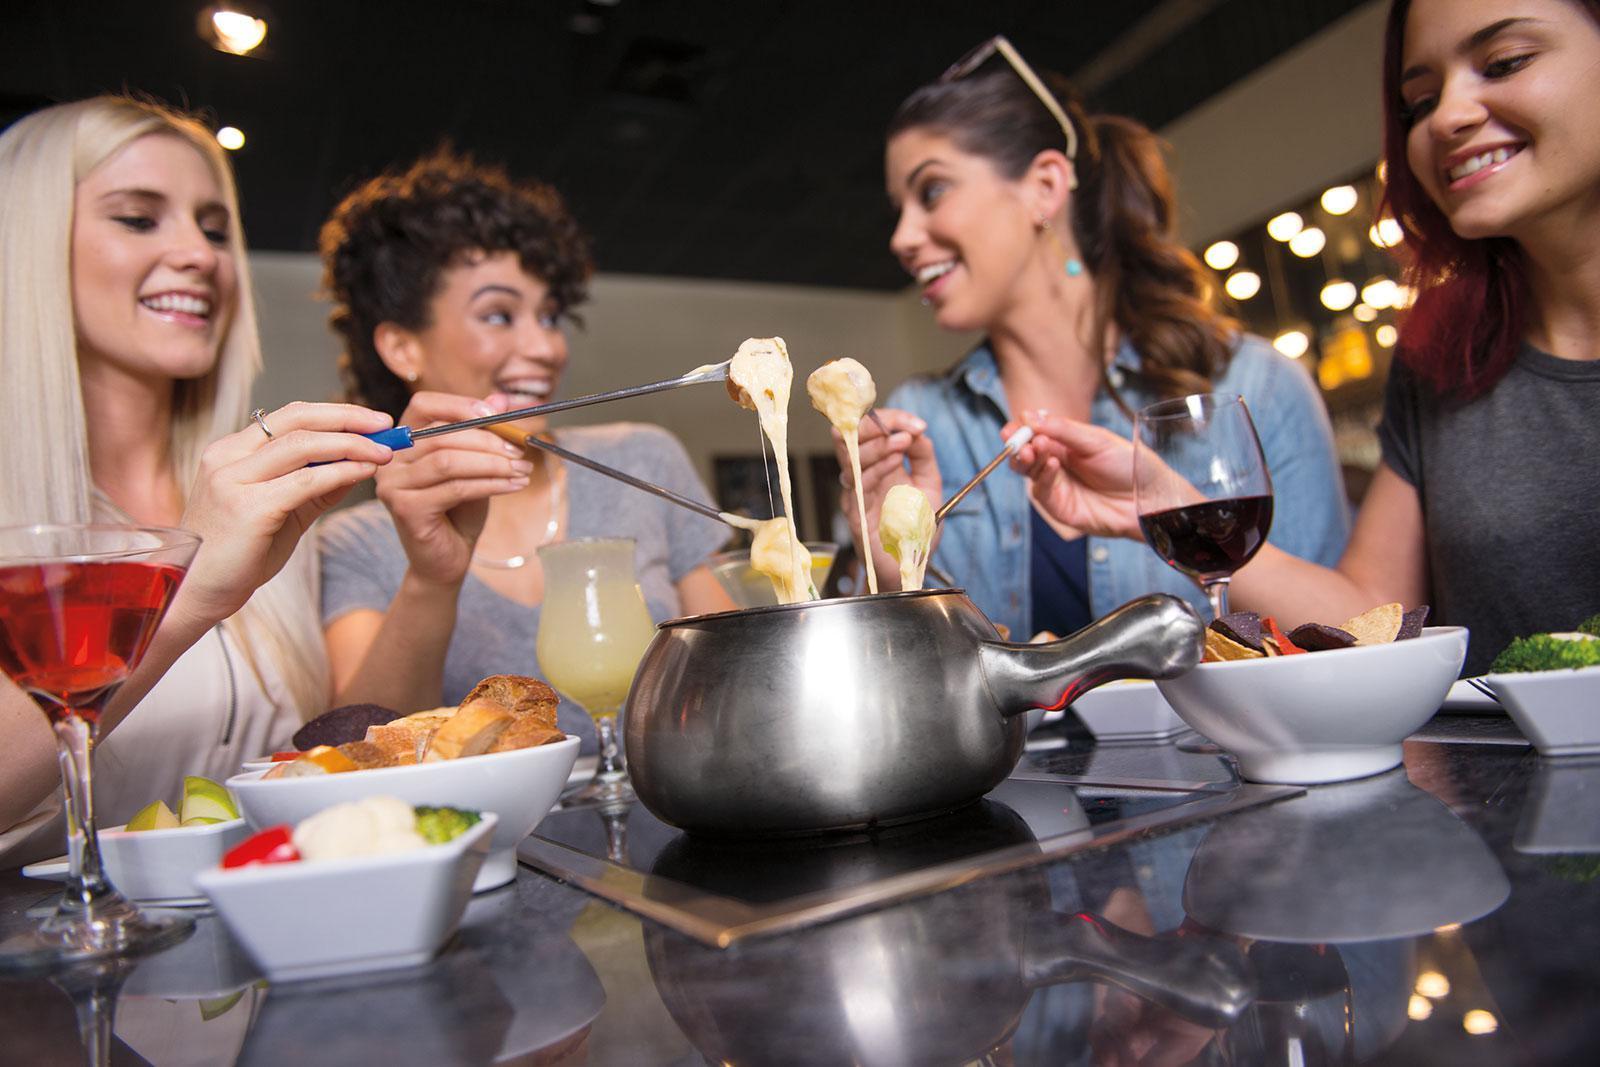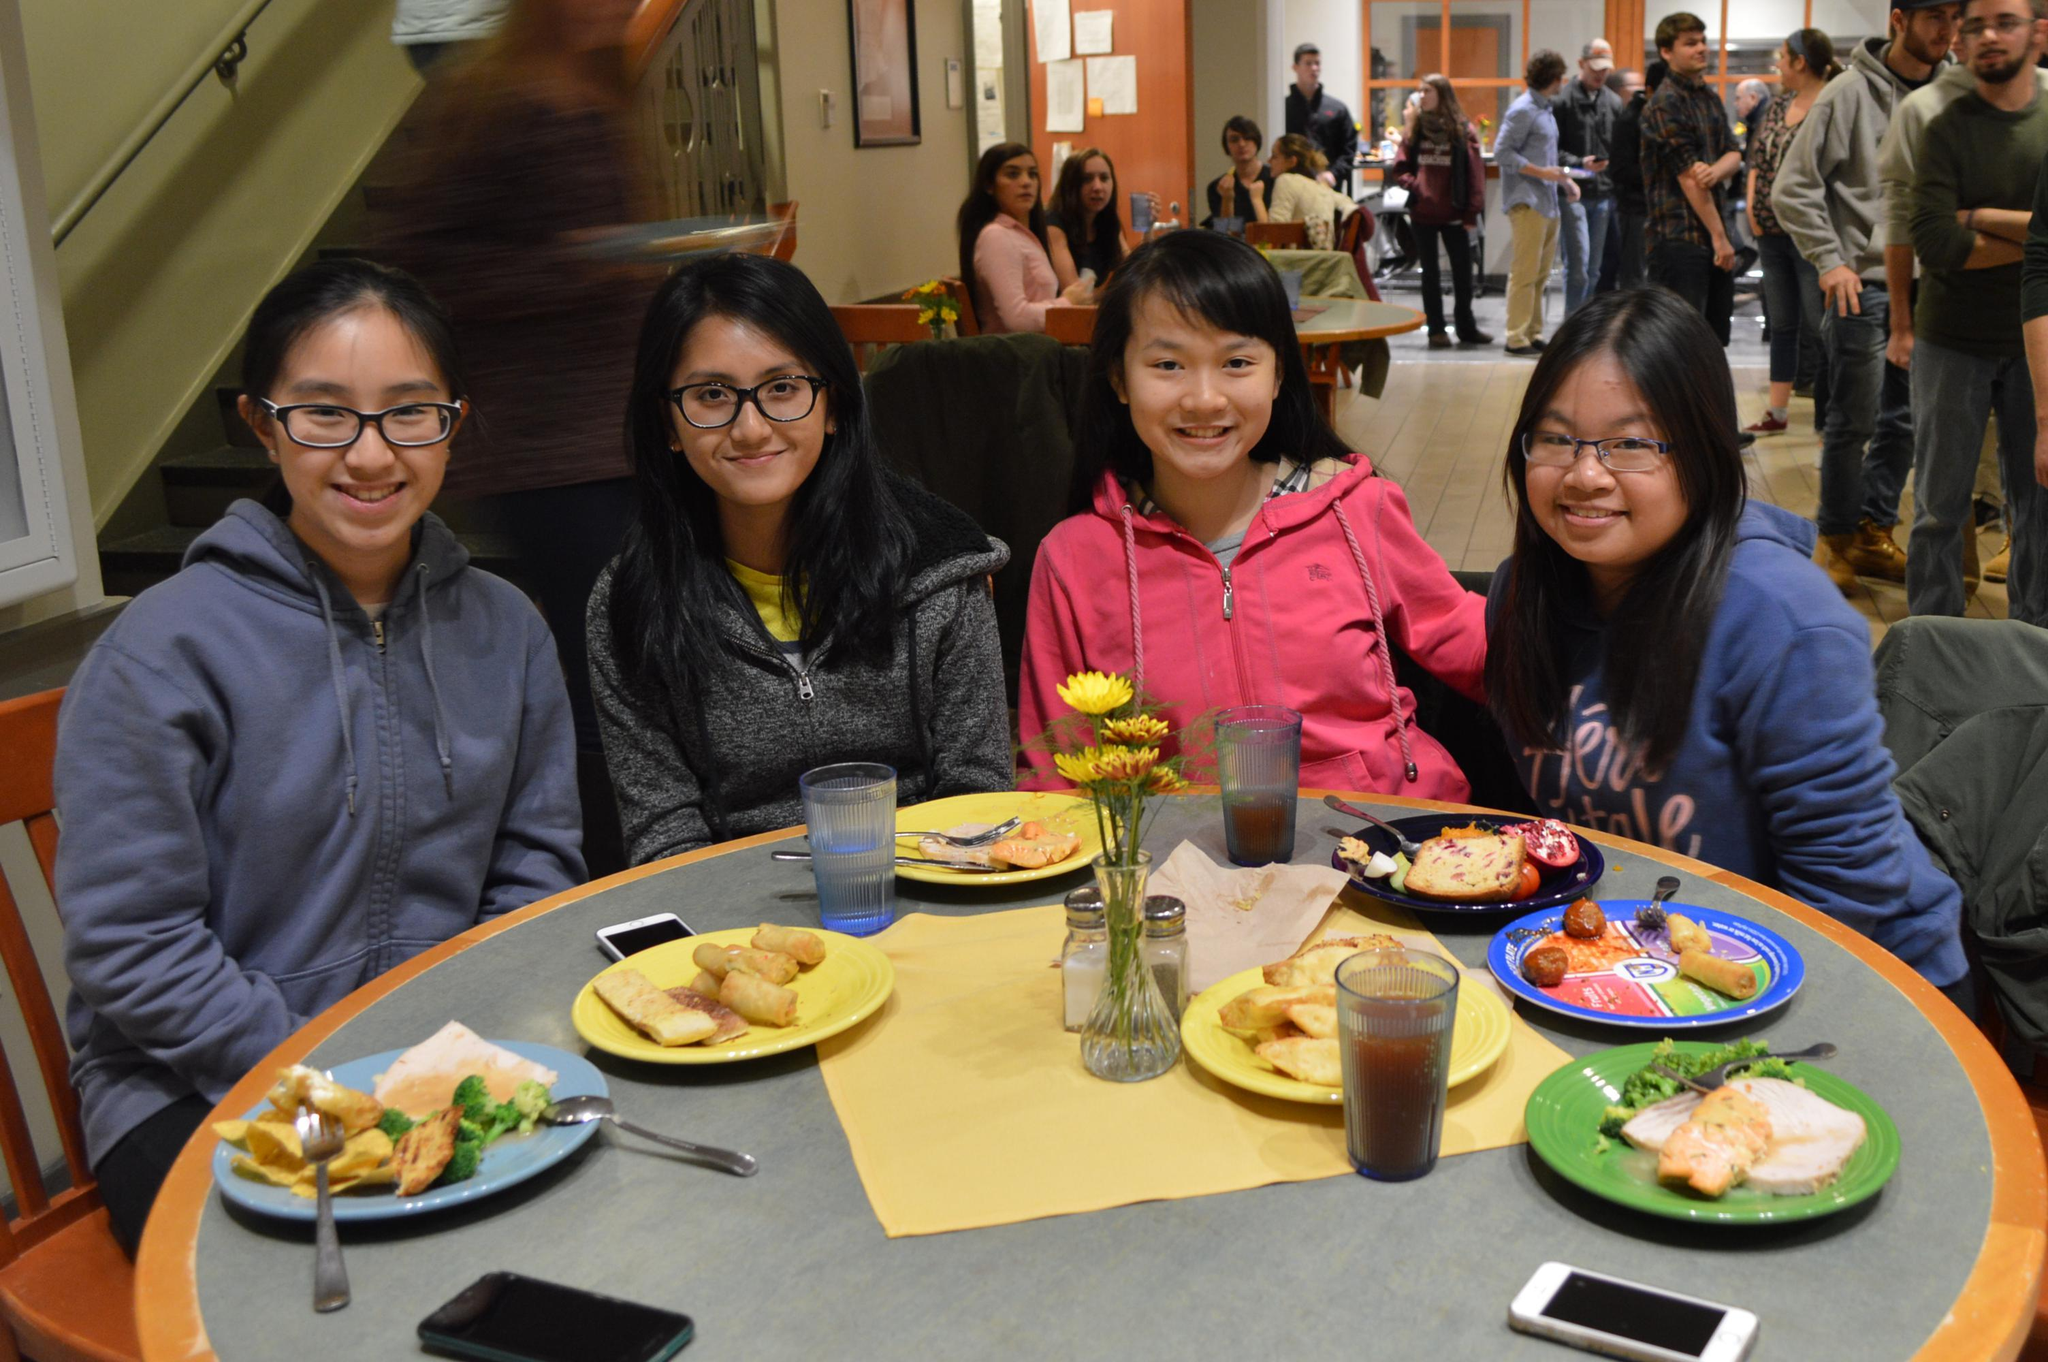The first image is the image on the left, the second image is the image on the right. Considering the images on both sides, is "The woman on the right at a table is lifting a forkful of food above a white plate, in the lefthand image." valid? Answer yes or no. No. 